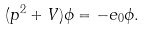<formula> <loc_0><loc_0><loc_500><loc_500>( p ^ { 2 } + V ) \phi = - e _ { 0 } \phi .</formula> 